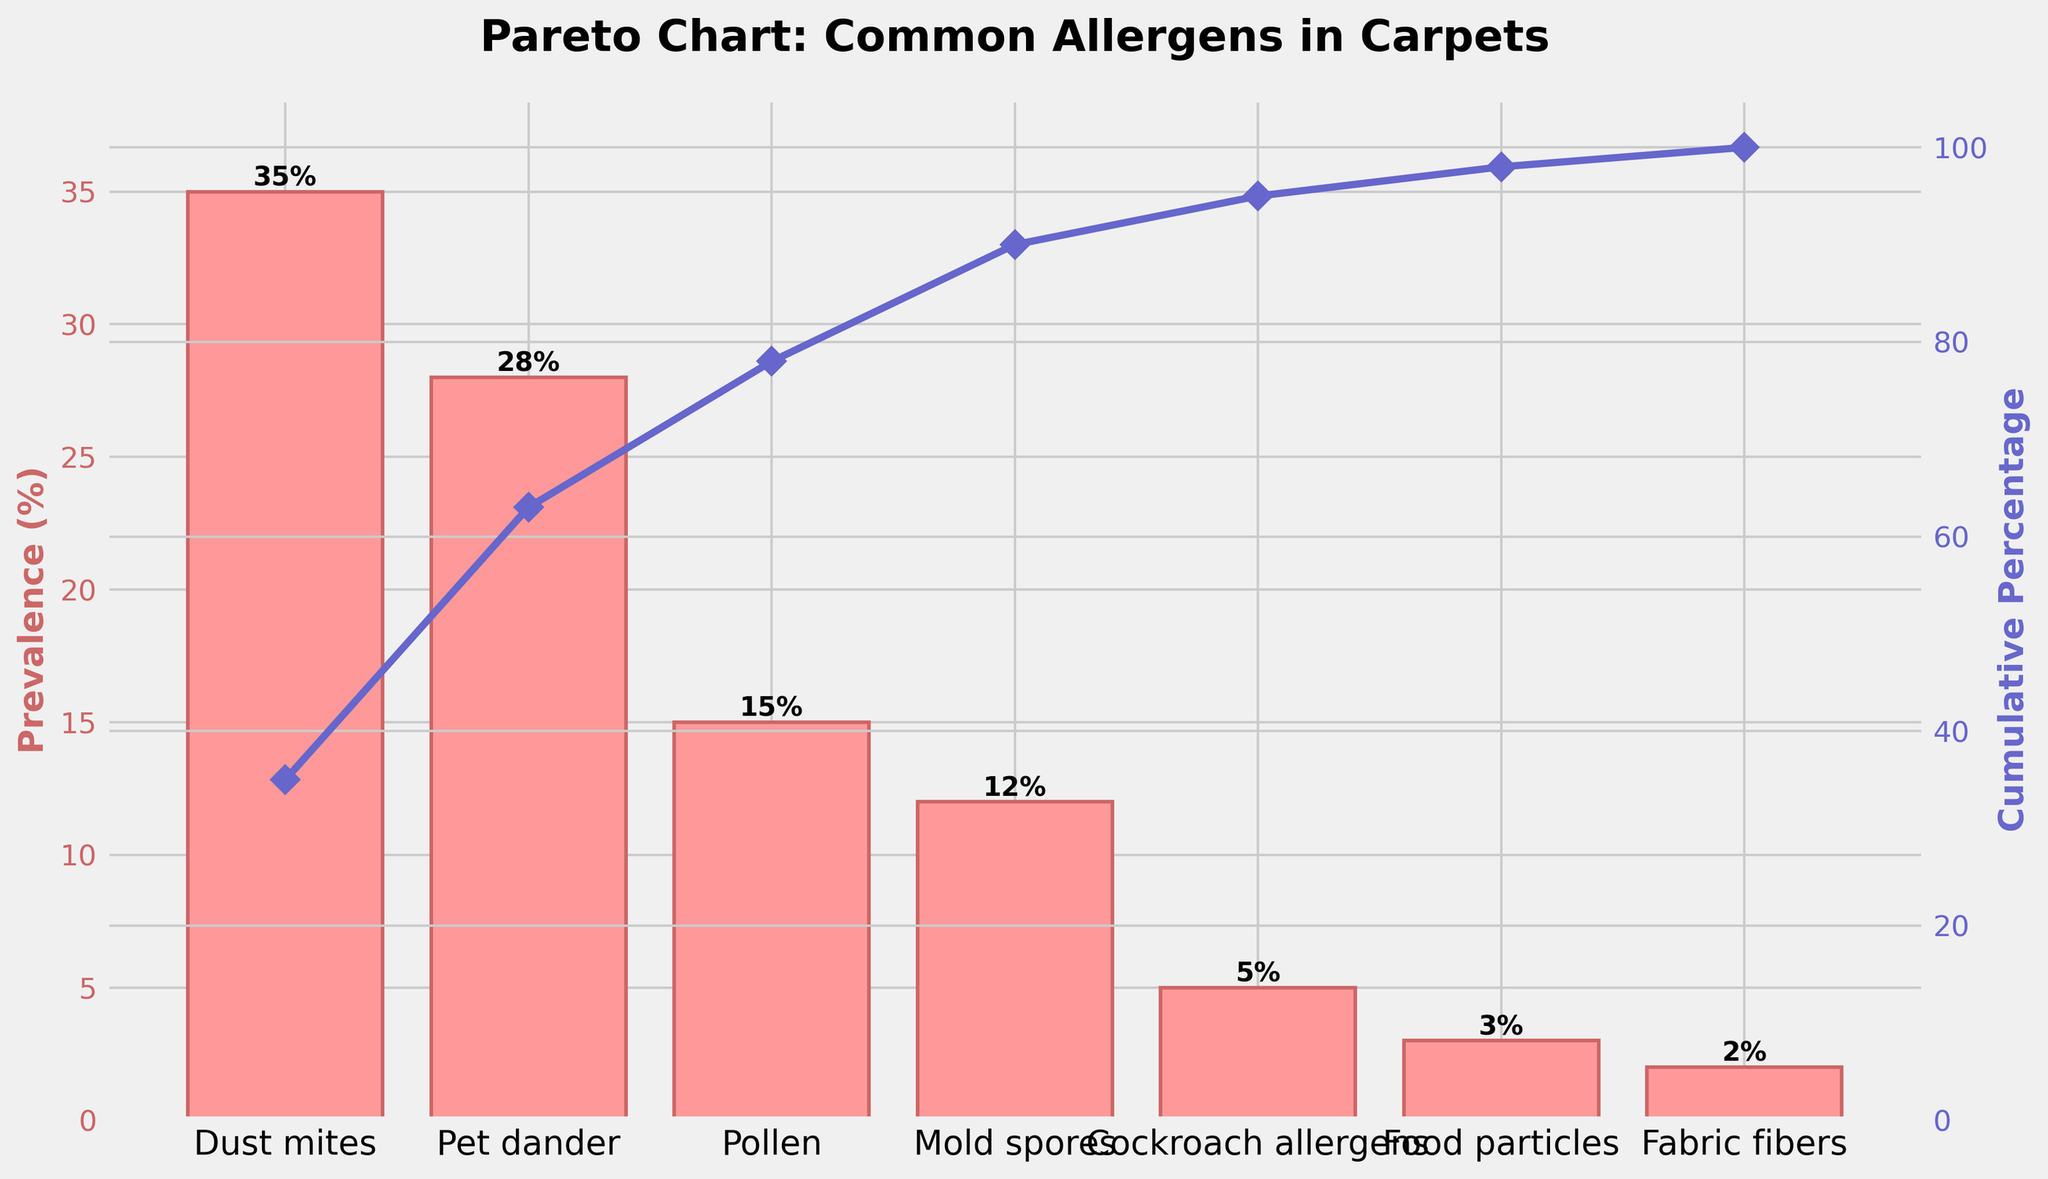What is the title of the figure? The title of the figure is typically the largest text at the top of the plot, so it can be identified easily. It provides the context and main subject of the plot.
Answer: Pareto Chart: Common Allergens in Carpets What is the prevalence percentage of dust mites? Locate the bar for dust mites. The height of the bar corresponds to its prevalence percentage, and this value is also labeled at the top of the bar.
Answer: 35% Which allergen has the lowest prevalence percentage? Scan the heights of all the bars to identify the shortest one, which represents the allergen with the lowest prevalence percentage.
Answer: Fabric fibers What is the cumulative percentage after adding the prevalence of dust mites and pet dander? The cumulative percentage for dust mites is 35%. Add this to the prevalence percentage of pet dander (28%) to get the total cumulative percentage. 35 + 28 = 63
Answer: 63% How many allergens have a prevalence percentage above 10%? Count the bars that have a height greater than 10%. These will represent the allergens with a prevalence percentage above 10%.
Answer: 4 Which two allergens have the closest prevalence percentages? Compare the heights of the bars to identify the two allergens with the most similar heights, indicating close prevalence percentages.
Answer: Cockroach allergens and food particles How does the prevalence percentage of pollen compare to that of mold spores? Find the bars for pollen and mold spores. Compare their heights to determine which one is higher and by how much.
Answer: Pollen is higher by 3% What is the cumulative percentage up to mold spores? Add the prevalence percentages of all allergens up to and including mold spores: 35% (dust mites) + 28% (pet dander) + 15% (pollen) + 12% (mold spores). The total is 90.
Answer: 90% Which allergen contributes to reaching the cumulative percentage of exactly 100%? The allergens contribute cumulatively. The last allergen listed (fabric fibers) will bring the total to 100% as you move from left to right.
Answer: Fabric fibers Based on the chart, what action might be most effective in reducing allergen preload in carpets? Identify the allergen with the highest prevalence and consider measures that target this allergen, as reducing its presence would have the greatest impact.
Answer: Reduce dust mites 